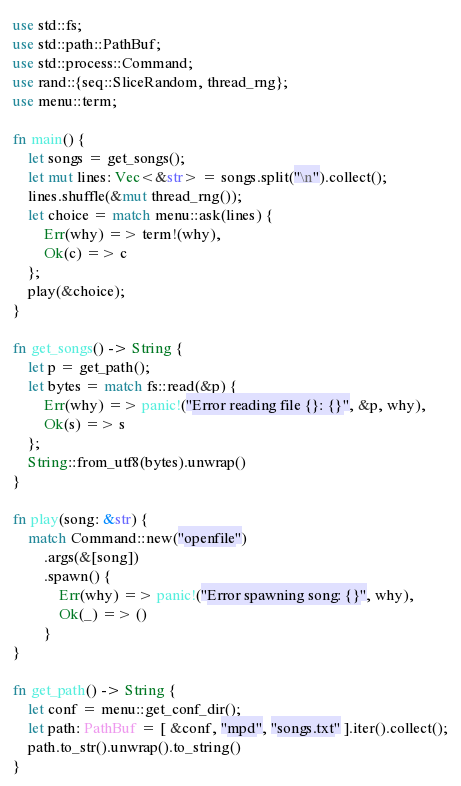Convert code to text. <code><loc_0><loc_0><loc_500><loc_500><_Rust_>use std::fs;
use std::path::PathBuf;
use std::process::Command;
use rand::{seq::SliceRandom, thread_rng};
use menu::term;

fn main() {
    let songs = get_songs();
    let mut lines: Vec<&str> = songs.split("\n").collect();
    lines.shuffle(&mut thread_rng());
    let choice = match menu::ask(lines) {
        Err(why) => term!(why),
        Ok(c) => c
    };
    play(&choice);
}

fn get_songs() -> String {
    let p = get_path();
    let bytes = match fs::read(&p) {
        Err(why) => panic!("Error reading file {}: {}", &p, why),
        Ok(s) => s
    };
    String::from_utf8(bytes).unwrap()
}

fn play(song: &str) {
    match Command::new("openfile")
        .args(&[song])
        .spawn() {
            Err(why) => panic!("Error spawning song: {}", why),
            Ok(_) => ()
        }
}

fn get_path() -> String {
    let conf = menu::get_conf_dir();
    let path: PathBuf = [ &conf, "mpd", "songs.txt" ].iter().collect();
    path.to_str().unwrap().to_string()
}
</code> 